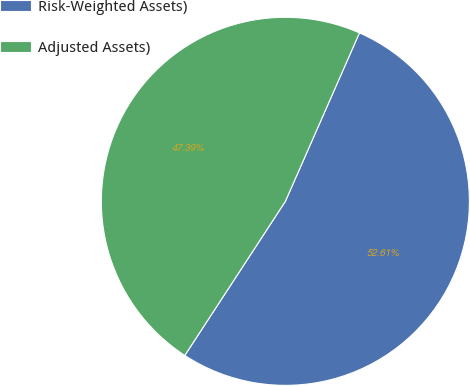<chart> <loc_0><loc_0><loc_500><loc_500><pie_chart><fcel>Risk-Weighted Assets)<fcel>Adjusted Assets)<nl><fcel>52.61%<fcel>47.39%<nl></chart> 